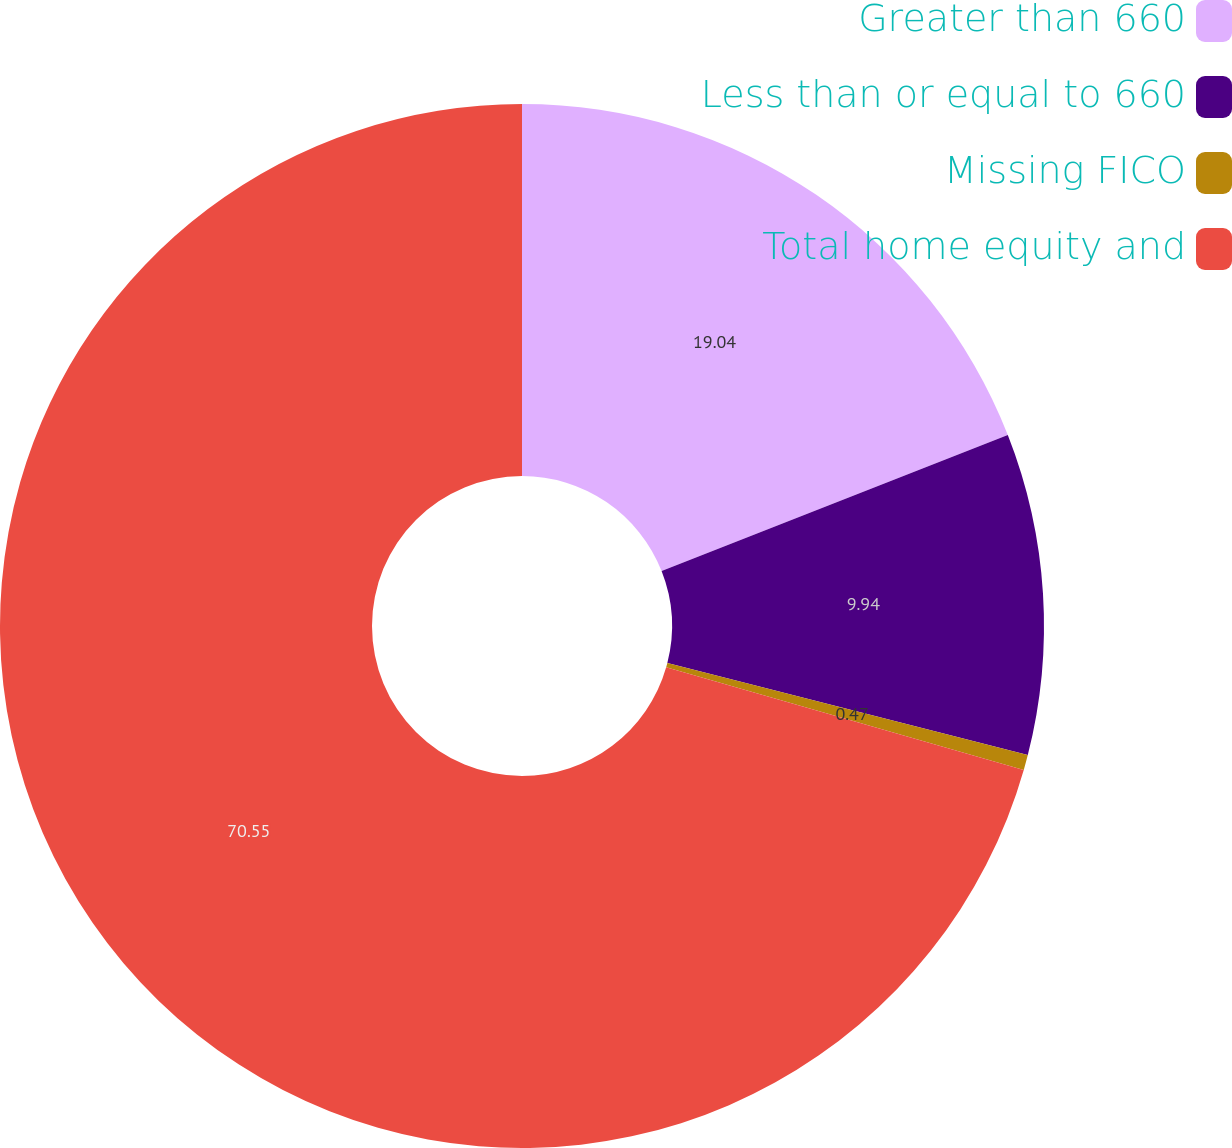<chart> <loc_0><loc_0><loc_500><loc_500><pie_chart><fcel>Greater than 660<fcel>Less than or equal to 660<fcel>Missing FICO<fcel>Total home equity and<nl><fcel>19.04%<fcel>9.94%<fcel>0.47%<fcel>70.56%<nl></chart> 